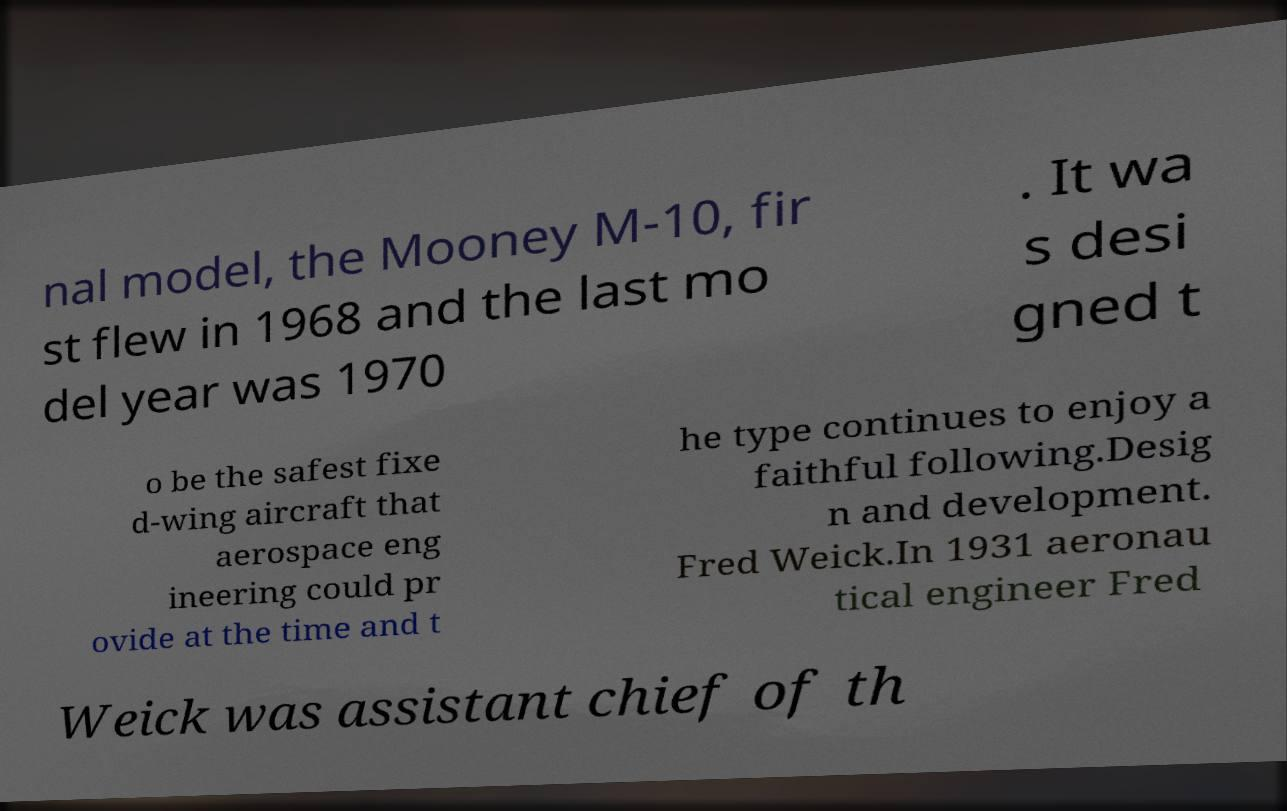Could you assist in decoding the text presented in this image and type it out clearly? nal model, the Mooney M-10, fir st flew in 1968 and the last mo del year was 1970 . It wa s desi gned t o be the safest fixe d-wing aircraft that aerospace eng ineering could pr ovide at the time and t he type continues to enjoy a faithful following.Desig n and development. Fred Weick.In 1931 aeronau tical engineer Fred Weick was assistant chief of th 